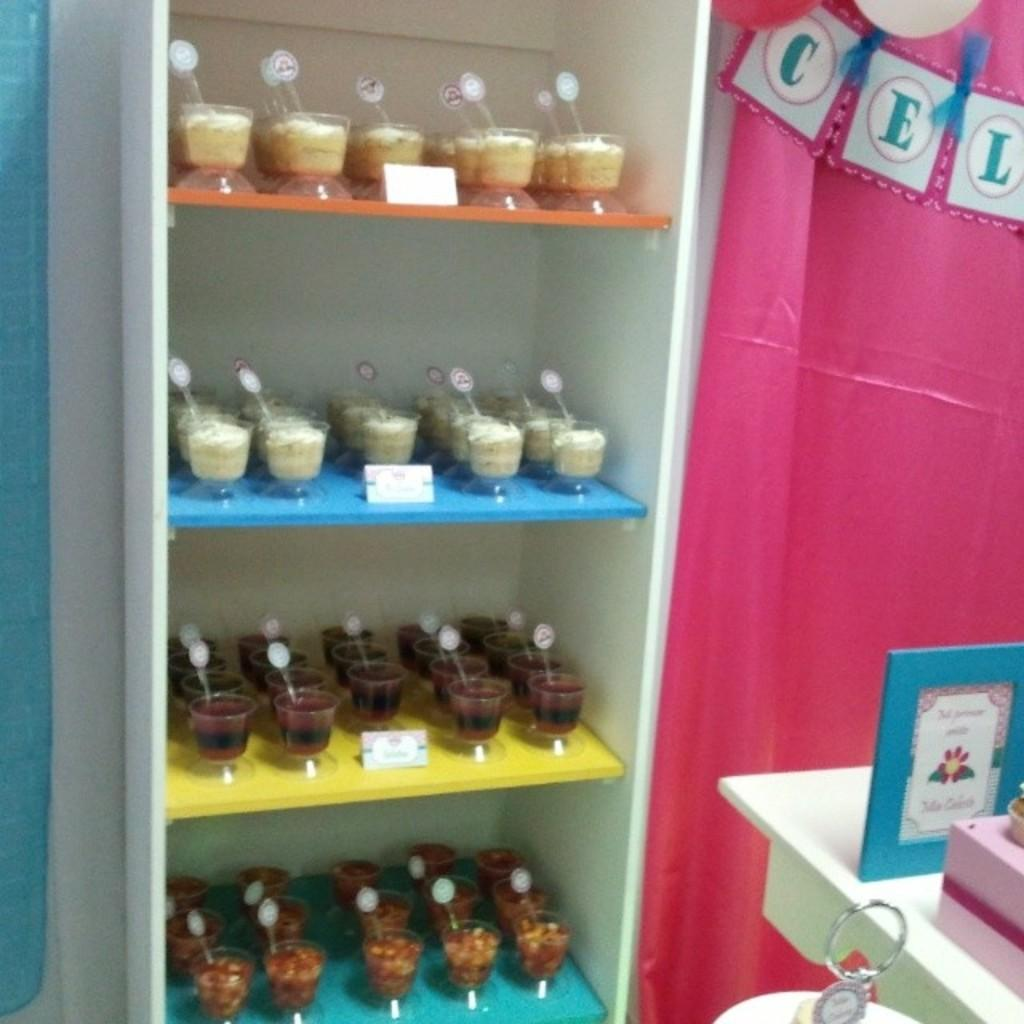What is present on the shelf in the image? There are food items on a shelf in the image. What else can be seen in the image besides the food items? There are curtains and frames visible in the image. Can you describe the decorative content in the image? Yes, there is decorative content in the image. What type of animal can be seen moving around in the image? There are no animals present in the image, and nothing is moving around. 